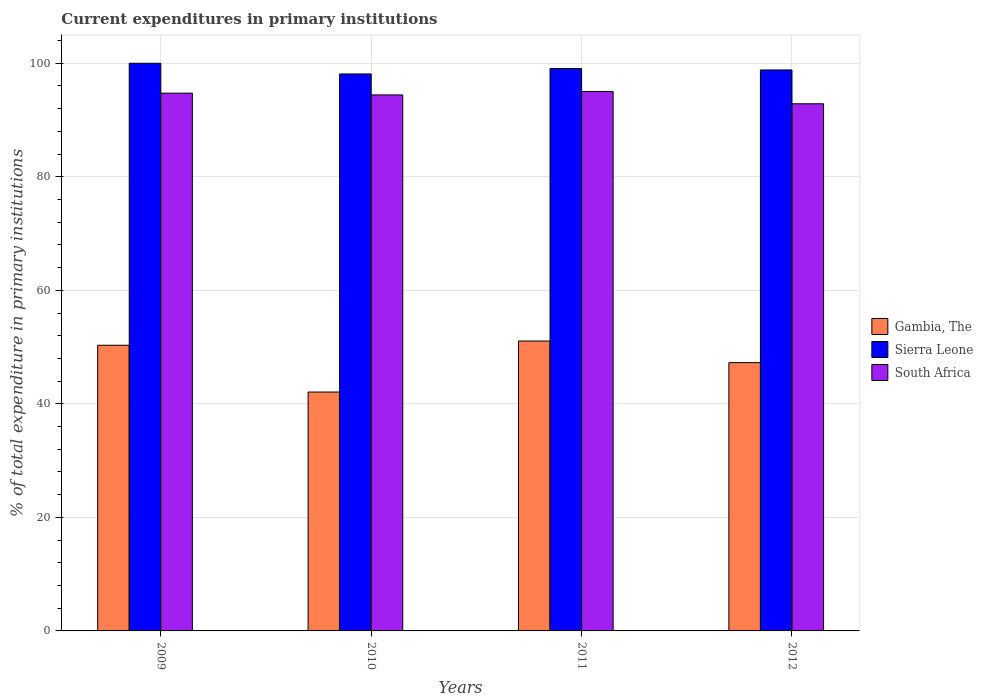How many different coloured bars are there?
Offer a very short reply. 3. Are the number of bars on each tick of the X-axis equal?
Your answer should be very brief. Yes. How many bars are there on the 1st tick from the left?
Ensure brevity in your answer.  3. How many bars are there on the 1st tick from the right?
Make the answer very short. 3. What is the current expenditures in primary institutions in Sierra Leone in 2012?
Offer a very short reply. 98.82. Across all years, what is the maximum current expenditures in primary institutions in Gambia, The?
Your response must be concise. 51.07. Across all years, what is the minimum current expenditures in primary institutions in Gambia, The?
Ensure brevity in your answer.  42.08. What is the total current expenditures in primary institutions in South Africa in the graph?
Provide a short and direct response. 377.05. What is the difference between the current expenditures in primary institutions in South Africa in 2011 and that in 2012?
Offer a very short reply. 2.17. What is the difference between the current expenditures in primary institutions in Sierra Leone in 2011 and the current expenditures in primary institutions in Gambia, The in 2010?
Your answer should be very brief. 56.98. What is the average current expenditures in primary institutions in Sierra Leone per year?
Your answer should be compact. 99. In the year 2012, what is the difference between the current expenditures in primary institutions in Gambia, The and current expenditures in primary institutions in South Africa?
Provide a succinct answer. -45.6. What is the ratio of the current expenditures in primary institutions in South Africa in 2010 to that in 2011?
Provide a short and direct response. 0.99. Is the current expenditures in primary institutions in South Africa in 2009 less than that in 2010?
Offer a very short reply. No. What is the difference between the highest and the second highest current expenditures in primary institutions in Gambia, The?
Make the answer very short. 0.74. What is the difference between the highest and the lowest current expenditures in primary institutions in Gambia, The?
Make the answer very short. 8.98. Is the sum of the current expenditures in primary institutions in Gambia, The in 2011 and 2012 greater than the maximum current expenditures in primary institutions in South Africa across all years?
Offer a very short reply. Yes. What does the 2nd bar from the left in 2010 represents?
Keep it short and to the point. Sierra Leone. What does the 1st bar from the right in 2010 represents?
Make the answer very short. South Africa. Is it the case that in every year, the sum of the current expenditures in primary institutions in Gambia, The and current expenditures in primary institutions in Sierra Leone is greater than the current expenditures in primary institutions in South Africa?
Make the answer very short. Yes. How many bars are there?
Offer a very short reply. 12. How many years are there in the graph?
Offer a very short reply. 4. Are the values on the major ticks of Y-axis written in scientific E-notation?
Your answer should be compact. No. Does the graph contain grids?
Your answer should be very brief. Yes. How many legend labels are there?
Your answer should be very brief. 3. How are the legend labels stacked?
Offer a terse response. Vertical. What is the title of the graph?
Provide a succinct answer. Current expenditures in primary institutions. What is the label or title of the Y-axis?
Provide a succinct answer. % of total expenditure in primary institutions. What is the % of total expenditure in primary institutions in Gambia, The in 2009?
Ensure brevity in your answer.  50.33. What is the % of total expenditure in primary institutions in Sierra Leone in 2009?
Offer a terse response. 100. What is the % of total expenditure in primary institutions of South Africa in 2009?
Offer a very short reply. 94.73. What is the % of total expenditure in primary institutions of Gambia, The in 2010?
Keep it short and to the point. 42.08. What is the % of total expenditure in primary institutions in Sierra Leone in 2010?
Provide a short and direct response. 98.12. What is the % of total expenditure in primary institutions of South Africa in 2010?
Offer a very short reply. 94.42. What is the % of total expenditure in primary institutions of Gambia, The in 2011?
Your response must be concise. 51.07. What is the % of total expenditure in primary institutions in Sierra Leone in 2011?
Provide a short and direct response. 99.07. What is the % of total expenditure in primary institutions of South Africa in 2011?
Offer a terse response. 95.03. What is the % of total expenditure in primary institutions of Gambia, The in 2012?
Keep it short and to the point. 47.26. What is the % of total expenditure in primary institutions in Sierra Leone in 2012?
Make the answer very short. 98.82. What is the % of total expenditure in primary institutions of South Africa in 2012?
Keep it short and to the point. 92.86. Across all years, what is the maximum % of total expenditure in primary institutions of Gambia, The?
Your response must be concise. 51.07. Across all years, what is the maximum % of total expenditure in primary institutions in Sierra Leone?
Provide a succinct answer. 100. Across all years, what is the maximum % of total expenditure in primary institutions in South Africa?
Your answer should be compact. 95.03. Across all years, what is the minimum % of total expenditure in primary institutions in Gambia, The?
Your answer should be very brief. 42.08. Across all years, what is the minimum % of total expenditure in primary institutions of Sierra Leone?
Keep it short and to the point. 98.12. Across all years, what is the minimum % of total expenditure in primary institutions of South Africa?
Keep it short and to the point. 92.86. What is the total % of total expenditure in primary institutions of Gambia, The in the graph?
Your answer should be very brief. 190.74. What is the total % of total expenditure in primary institutions in Sierra Leone in the graph?
Your response must be concise. 396. What is the total % of total expenditure in primary institutions in South Africa in the graph?
Ensure brevity in your answer.  377.05. What is the difference between the % of total expenditure in primary institutions in Gambia, The in 2009 and that in 2010?
Give a very brief answer. 8.24. What is the difference between the % of total expenditure in primary institutions of Sierra Leone in 2009 and that in 2010?
Offer a terse response. 1.88. What is the difference between the % of total expenditure in primary institutions in South Africa in 2009 and that in 2010?
Your answer should be very brief. 0.31. What is the difference between the % of total expenditure in primary institutions in Gambia, The in 2009 and that in 2011?
Ensure brevity in your answer.  -0.74. What is the difference between the % of total expenditure in primary institutions of Sierra Leone in 2009 and that in 2011?
Your answer should be very brief. 0.93. What is the difference between the % of total expenditure in primary institutions of South Africa in 2009 and that in 2011?
Provide a succinct answer. -0.3. What is the difference between the % of total expenditure in primary institutions in Gambia, The in 2009 and that in 2012?
Make the answer very short. 3.07. What is the difference between the % of total expenditure in primary institutions in Sierra Leone in 2009 and that in 2012?
Your response must be concise. 1.18. What is the difference between the % of total expenditure in primary institutions in South Africa in 2009 and that in 2012?
Your answer should be compact. 1.87. What is the difference between the % of total expenditure in primary institutions in Gambia, The in 2010 and that in 2011?
Your answer should be very brief. -8.98. What is the difference between the % of total expenditure in primary institutions of Sierra Leone in 2010 and that in 2011?
Your answer should be compact. -0.95. What is the difference between the % of total expenditure in primary institutions in South Africa in 2010 and that in 2011?
Provide a succinct answer. -0.61. What is the difference between the % of total expenditure in primary institutions in Gambia, The in 2010 and that in 2012?
Ensure brevity in your answer.  -5.18. What is the difference between the % of total expenditure in primary institutions in Sierra Leone in 2010 and that in 2012?
Give a very brief answer. -0.7. What is the difference between the % of total expenditure in primary institutions of South Africa in 2010 and that in 2012?
Keep it short and to the point. 1.56. What is the difference between the % of total expenditure in primary institutions in Gambia, The in 2011 and that in 2012?
Provide a short and direct response. 3.8. What is the difference between the % of total expenditure in primary institutions of Sierra Leone in 2011 and that in 2012?
Offer a terse response. 0.25. What is the difference between the % of total expenditure in primary institutions of South Africa in 2011 and that in 2012?
Keep it short and to the point. 2.17. What is the difference between the % of total expenditure in primary institutions in Gambia, The in 2009 and the % of total expenditure in primary institutions in Sierra Leone in 2010?
Make the answer very short. -47.79. What is the difference between the % of total expenditure in primary institutions in Gambia, The in 2009 and the % of total expenditure in primary institutions in South Africa in 2010?
Your answer should be compact. -44.1. What is the difference between the % of total expenditure in primary institutions of Sierra Leone in 2009 and the % of total expenditure in primary institutions of South Africa in 2010?
Give a very brief answer. 5.58. What is the difference between the % of total expenditure in primary institutions of Gambia, The in 2009 and the % of total expenditure in primary institutions of Sierra Leone in 2011?
Your answer should be compact. -48.74. What is the difference between the % of total expenditure in primary institutions of Gambia, The in 2009 and the % of total expenditure in primary institutions of South Africa in 2011?
Give a very brief answer. -44.7. What is the difference between the % of total expenditure in primary institutions in Sierra Leone in 2009 and the % of total expenditure in primary institutions in South Africa in 2011?
Provide a short and direct response. 4.97. What is the difference between the % of total expenditure in primary institutions of Gambia, The in 2009 and the % of total expenditure in primary institutions of Sierra Leone in 2012?
Provide a succinct answer. -48.49. What is the difference between the % of total expenditure in primary institutions in Gambia, The in 2009 and the % of total expenditure in primary institutions in South Africa in 2012?
Provide a succinct answer. -42.54. What is the difference between the % of total expenditure in primary institutions in Sierra Leone in 2009 and the % of total expenditure in primary institutions in South Africa in 2012?
Provide a short and direct response. 7.14. What is the difference between the % of total expenditure in primary institutions of Gambia, The in 2010 and the % of total expenditure in primary institutions of Sierra Leone in 2011?
Offer a terse response. -56.98. What is the difference between the % of total expenditure in primary institutions of Gambia, The in 2010 and the % of total expenditure in primary institutions of South Africa in 2011?
Give a very brief answer. -52.95. What is the difference between the % of total expenditure in primary institutions in Sierra Leone in 2010 and the % of total expenditure in primary institutions in South Africa in 2011?
Give a very brief answer. 3.08. What is the difference between the % of total expenditure in primary institutions in Gambia, The in 2010 and the % of total expenditure in primary institutions in Sierra Leone in 2012?
Provide a succinct answer. -56.74. What is the difference between the % of total expenditure in primary institutions of Gambia, The in 2010 and the % of total expenditure in primary institutions of South Africa in 2012?
Ensure brevity in your answer.  -50.78. What is the difference between the % of total expenditure in primary institutions in Sierra Leone in 2010 and the % of total expenditure in primary institutions in South Africa in 2012?
Offer a terse response. 5.25. What is the difference between the % of total expenditure in primary institutions of Gambia, The in 2011 and the % of total expenditure in primary institutions of Sierra Leone in 2012?
Your response must be concise. -47.75. What is the difference between the % of total expenditure in primary institutions of Gambia, The in 2011 and the % of total expenditure in primary institutions of South Africa in 2012?
Your response must be concise. -41.8. What is the difference between the % of total expenditure in primary institutions in Sierra Leone in 2011 and the % of total expenditure in primary institutions in South Africa in 2012?
Ensure brevity in your answer.  6.2. What is the average % of total expenditure in primary institutions of Gambia, The per year?
Ensure brevity in your answer.  47.68. What is the average % of total expenditure in primary institutions in South Africa per year?
Keep it short and to the point. 94.26. In the year 2009, what is the difference between the % of total expenditure in primary institutions of Gambia, The and % of total expenditure in primary institutions of Sierra Leone?
Ensure brevity in your answer.  -49.67. In the year 2009, what is the difference between the % of total expenditure in primary institutions of Gambia, The and % of total expenditure in primary institutions of South Africa?
Provide a short and direct response. -44.41. In the year 2009, what is the difference between the % of total expenditure in primary institutions of Sierra Leone and % of total expenditure in primary institutions of South Africa?
Ensure brevity in your answer.  5.27. In the year 2010, what is the difference between the % of total expenditure in primary institutions in Gambia, The and % of total expenditure in primary institutions in Sierra Leone?
Your response must be concise. -56.03. In the year 2010, what is the difference between the % of total expenditure in primary institutions of Gambia, The and % of total expenditure in primary institutions of South Africa?
Offer a very short reply. -52.34. In the year 2010, what is the difference between the % of total expenditure in primary institutions of Sierra Leone and % of total expenditure in primary institutions of South Africa?
Give a very brief answer. 3.69. In the year 2011, what is the difference between the % of total expenditure in primary institutions of Gambia, The and % of total expenditure in primary institutions of Sierra Leone?
Give a very brief answer. -48. In the year 2011, what is the difference between the % of total expenditure in primary institutions of Gambia, The and % of total expenditure in primary institutions of South Africa?
Make the answer very short. -43.97. In the year 2011, what is the difference between the % of total expenditure in primary institutions in Sierra Leone and % of total expenditure in primary institutions in South Africa?
Give a very brief answer. 4.03. In the year 2012, what is the difference between the % of total expenditure in primary institutions of Gambia, The and % of total expenditure in primary institutions of Sierra Leone?
Your answer should be very brief. -51.56. In the year 2012, what is the difference between the % of total expenditure in primary institutions of Gambia, The and % of total expenditure in primary institutions of South Africa?
Offer a terse response. -45.6. In the year 2012, what is the difference between the % of total expenditure in primary institutions of Sierra Leone and % of total expenditure in primary institutions of South Africa?
Offer a very short reply. 5.96. What is the ratio of the % of total expenditure in primary institutions in Gambia, The in 2009 to that in 2010?
Keep it short and to the point. 1.2. What is the ratio of the % of total expenditure in primary institutions of Sierra Leone in 2009 to that in 2010?
Ensure brevity in your answer.  1.02. What is the ratio of the % of total expenditure in primary institutions in Gambia, The in 2009 to that in 2011?
Ensure brevity in your answer.  0.99. What is the ratio of the % of total expenditure in primary institutions of Sierra Leone in 2009 to that in 2011?
Make the answer very short. 1.01. What is the ratio of the % of total expenditure in primary institutions of South Africa in 2009 to that in 2011?
Provide a short and direct response. 1. What is the ratio of the % of total expenditure in primary institutions in Gambia, The in 2009 to that in 2012?
Offer a very short reply. 1.06. What is the ratio of the % of total expenditure in primary institutions in Sierra Leone in 2009 to that in 2012?
Offer a terse response. 1.01. What is the ratio of the % of total expenditure in primary institutions in South Africa in 2009 to that in 2012?
Your answer should be compact. 1.02. What is the ratio of the % of total expenditure in primary institutions in Gambia, The in 2010 to that in 2011?
Offer a terse response. 0.82. What is the ratio of the % of total expenditure in primary institutions in South Africa in 2010 to that in 2011?
Your response must be concise. 0.99. What is the ratio of the % of total expenditure in primary institutions in Gambia, The in 2010 to that in 2012?
Ensure brevity in your answer.  0.89. What is the ratio of the % of total expenditure in primary institutions in South Africa in 2010 to that in 2012?
Provide a succinct answer. 1.02. What is the ratio of the % of total expenditure in primary institutions in Gambia, The in 2011 to that in 2012?
Keep it short and to the point. 1.08. What is the ratio of the % of total expenditure in primary institutions of South Africa in 2011 to that in 2012?
Your answer should be compact. 1.02. What is the difference between the highest and the second highest % of total expenditure in primary institutions of Gambia, The?
Keep it short and to the point. 0.74. What is the difference between the highest and the second highest % of total expenditure in primary institutions in Sierra Leone?
Offer a terse response. 0.93. What is the difference between the highest and the second highest % of total expenditure in primary institutions of South Africa?
Ensure brevity in your answer.  0.3. What is the difference between the highest and the lowest % of total expenditure in primary institutions in Gambia, The?
Ensure brevity in your answer.  8.98. What is the difference between the highest and the lowest % of total expenditure in primary institutions in Sierra Leone?
Make the answer very short. 1.88. What is the difference between the highest and the lowest % of total expenditure in primary institutions in South Africa?
Your answer should be compact. 2.17. 